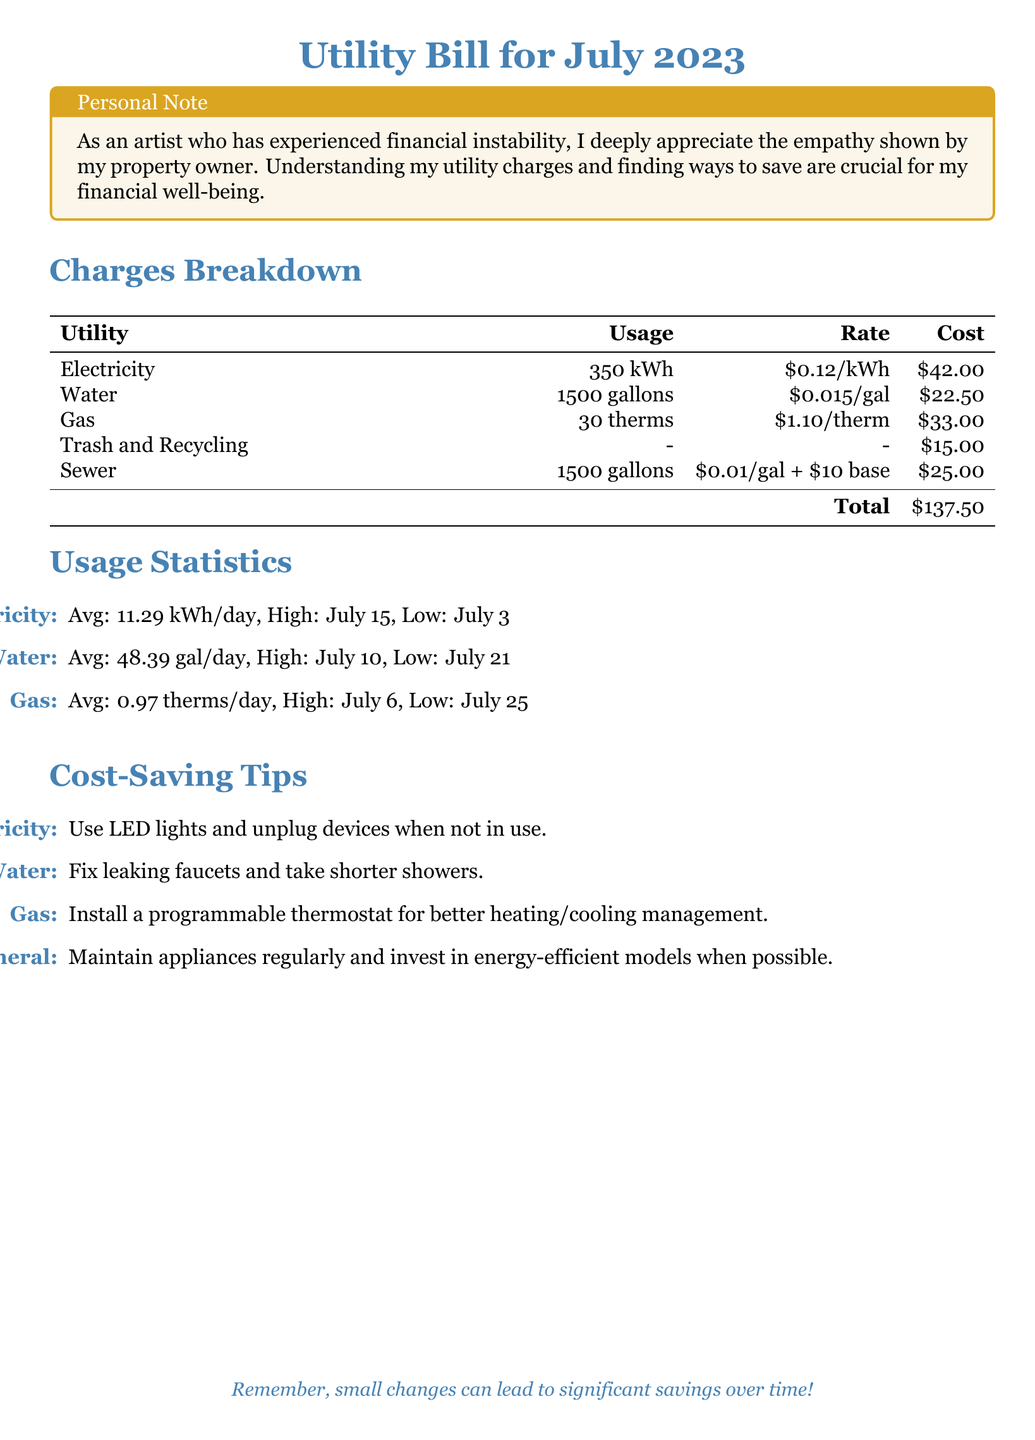What is the cost of electricity? The cost of electricity is specified in the Charges Breakdown section, which lists it as $42.00.
Answer: $42.00 What is the total cost of the utility bill? The total cost is calculated by summing all the utility charges listed in the Charges Breakdown, which equals $137.50.
Answer: $137.50 What was the average daily water usage? The average daily water usage is mentioned in the Usage Statistics section, which states it as 48.39 gallons per day.
Answer: 48.39 gallons How much did the property owner charge for gas? The Charges Breakdown outlines the gas charge as $33.00.
Answer: $33.00 What is one cost-saving tip for electricity? The Cost-Saving Tips section suggests using LED lights and unplugging devices when not in use.
Answer: Use LED lights What was the high usage day for gas? The Usage Statistics section indicates that the high usage day for gas was July 6.
Answer: July 6 What is the usage rate for water? The Charges Breakdown specifies the water usage rate as $0.015 per gallon.
Answer: $0.015/gal Which utility incurred the highest charge? By analyzing the Charges Breakdown, gas incurred the highest charge at $33.00.
Answer: Gas What is the rate for sewer usage? The sewer rate is described in the Charges Breakdown as $0.01 per gallon plus a $10 base fee.
Answer: $0.01/gal + $10 base 